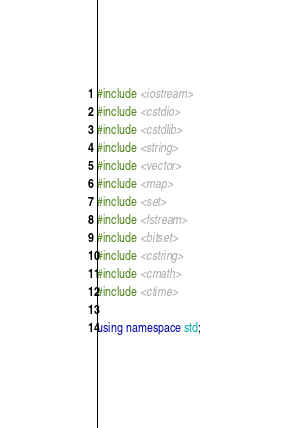Convert code to text. <code><loc_0><loc_0><loc_500><loc_500><_C++_>#include <iostream>
#include <cstdio>
#include <cstdlib>
#include <string>
#include <vector>
#include <map>
#include <set>
#include <fstream>
#include <bitset>
#include <cstring>
#include <cmath>
#include <ctime>

using namespace std;
</code> 